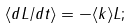Convert formula to latex. <formula><loc_0><loc_0><loc_500><loc_500>\langle d L / d t \rangle = - \langle k \rangle L ;</formula> 